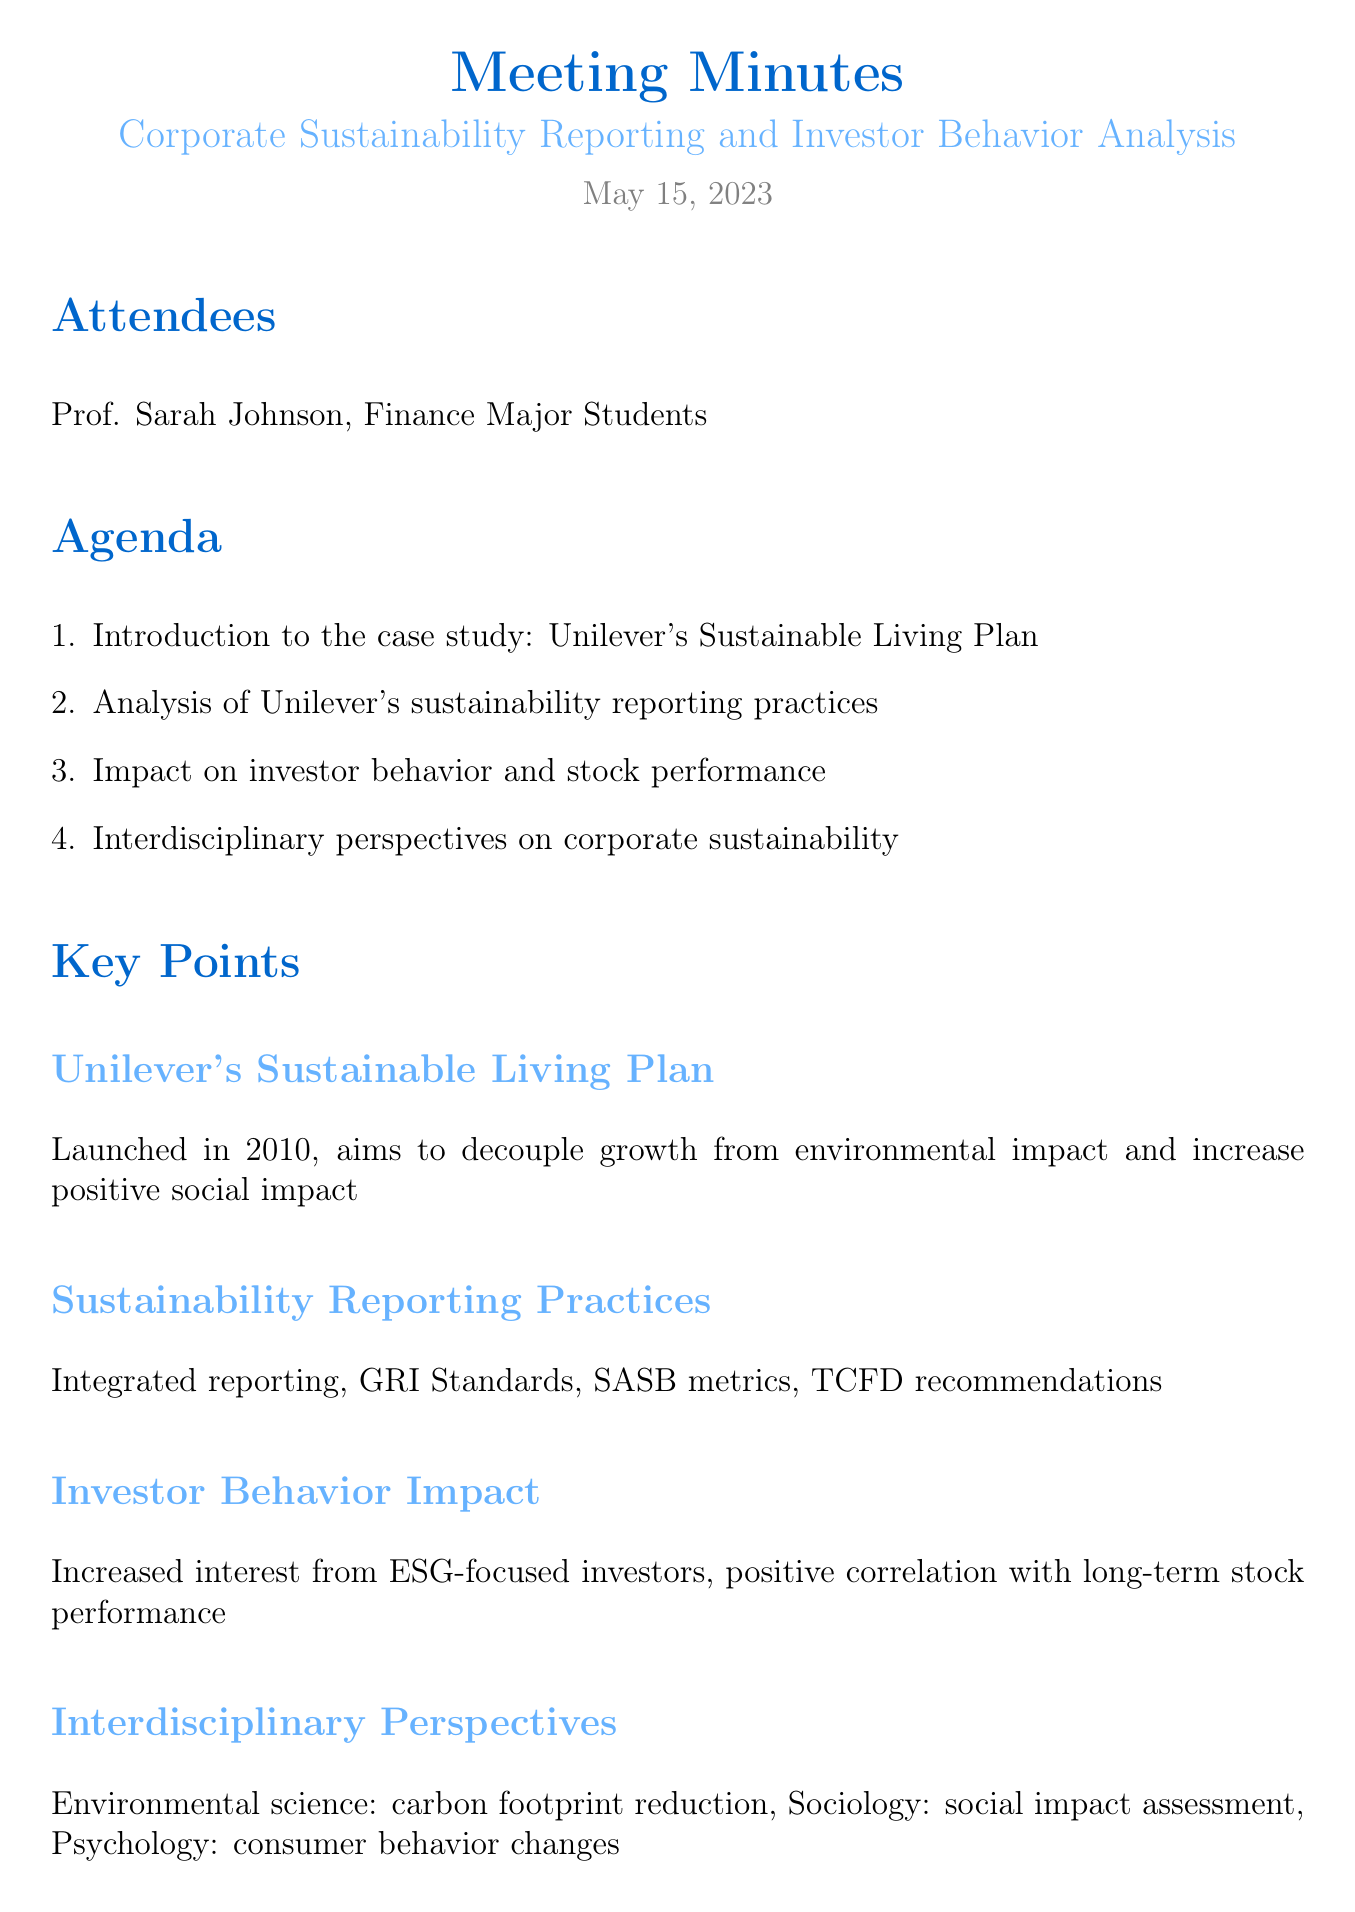What was the date of the meeting? The date of the meeting is explicitly listed at the beginning of the document.
Answer: May 15, 2023 Who is the professor leading the meeting? The professor's name is mentioned in the list of attendees at the start of the document.
Answer: Prof. Sarah Johnson What is the focus of the case study discussed? The case study discussed is specified in the agenda section of the document.
Answer: Unilever's Sustainable Living Plan What sustainability reporting practices were analyzed? Various reporting practices are detailed in the key points section of the document, outlining standards and metrics.
Answer: Integrated reporting, GRI Standards, SASB metrics, TCFD recommendations How much faster did Sustainable Living Brands grow compared to the rest of the business in 2018? The growth rate is provided as a specific percentage in the financial implications section.
Answer: 69% What was the performance of Unilever's stock compared to the FTSE 100 index over 5 years? This information is found in the financial implications section, comparing stock performance.
Answer: Outperformed FTSE 100 index by 8% What did the meeting emphasize about sustainability reporting? Conclusions drawn in the meeting highlight the significance of a certain type of reporting.
Answer: Importance of transparent and comprehensive sustainability reporting What follow-up action involves ESG ratings? A specific follow-up action is stated, focusing on a correlation related to ESG ratings.
Answer: Analyze correlation between ESG ratings and stock performance 